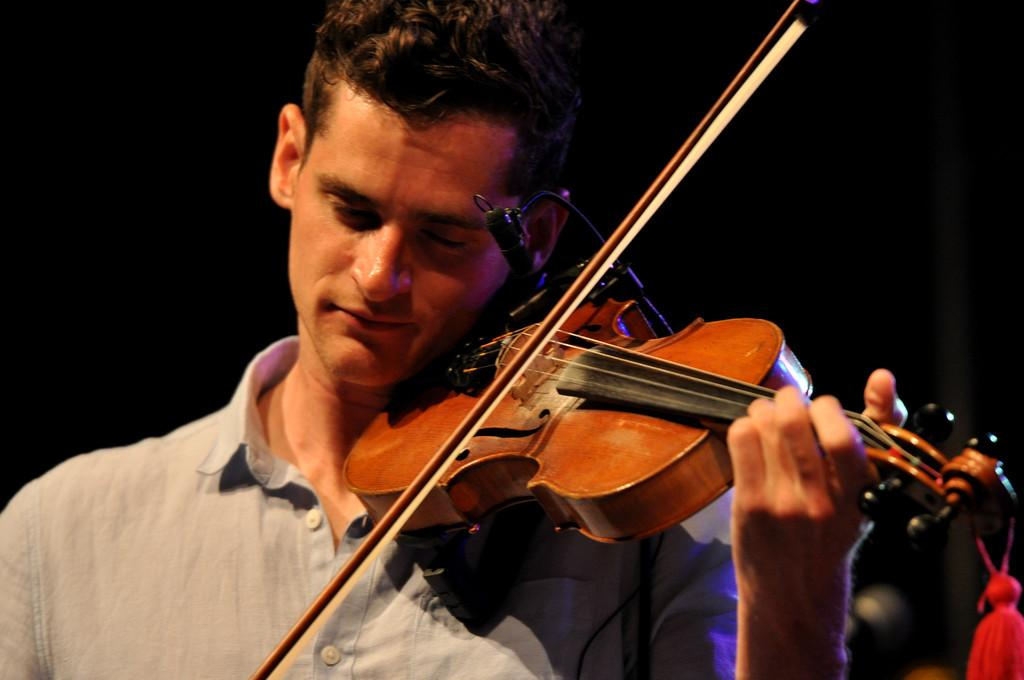What is the main subject of the image? There is a man in the image. What is the man doing in the image? The man is playing a violin. Where is the man located in the image? The man is in the center of the image. How many cherries are on the violin in the image? There are no cherries present in the image, and the violin is not mentioned as having any cherries on it. 